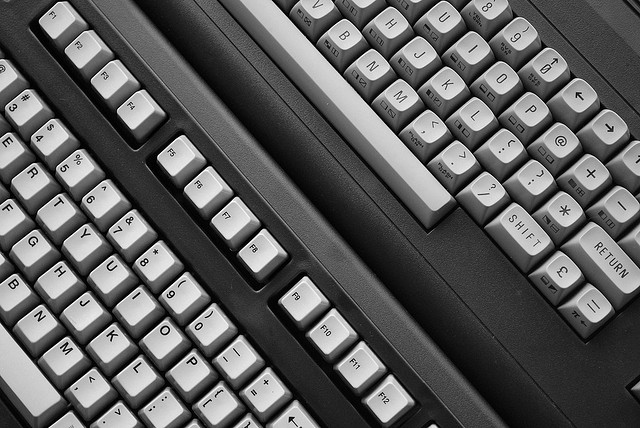Can you identify the type of device shown in this image? Certainly! The image displays a typewriter keyboard, which is part of a mechanical or electromechanical machine for writing characters similar to those produced by printers' movable type. 